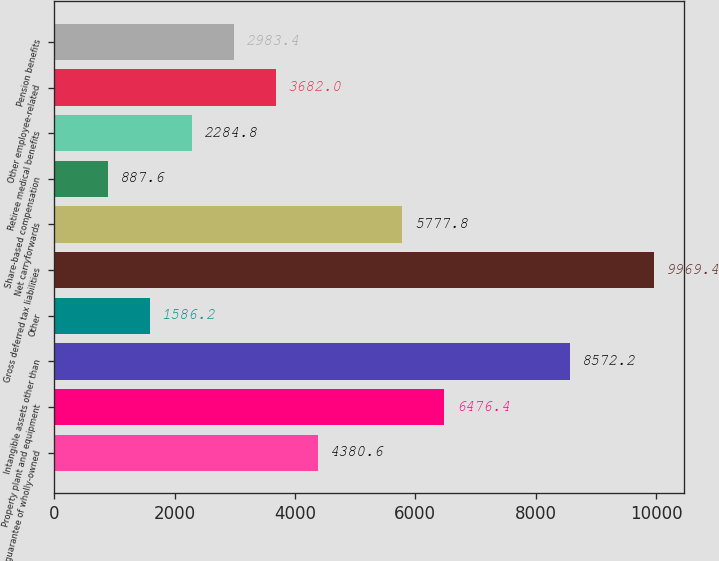Convert chart to OTSL. <chart><loc_0><loc_0><loc_500><loc_500><bar_chart><fcel>Debt guarantee of wholly-owned<fcel>Property plant and equipment<fcel>Intangible assets other than<fcel>Other<fcel>Gross deferred tax liabilities<fcel>Net carryforwards<fcel>Share-based compensation<fcel>Retiree medical benefits<fcel>Other employee-related<fcel>Pension benefits<nl><fcel>4380.6<fcel>6476.4<fcel>8572.2<fcel>1586.2<fcel>9969.4<fcel>5777.8<fcel>887.6<fcel>2284.8<fcel>3682<fcel>2983.4<nl></chart> 